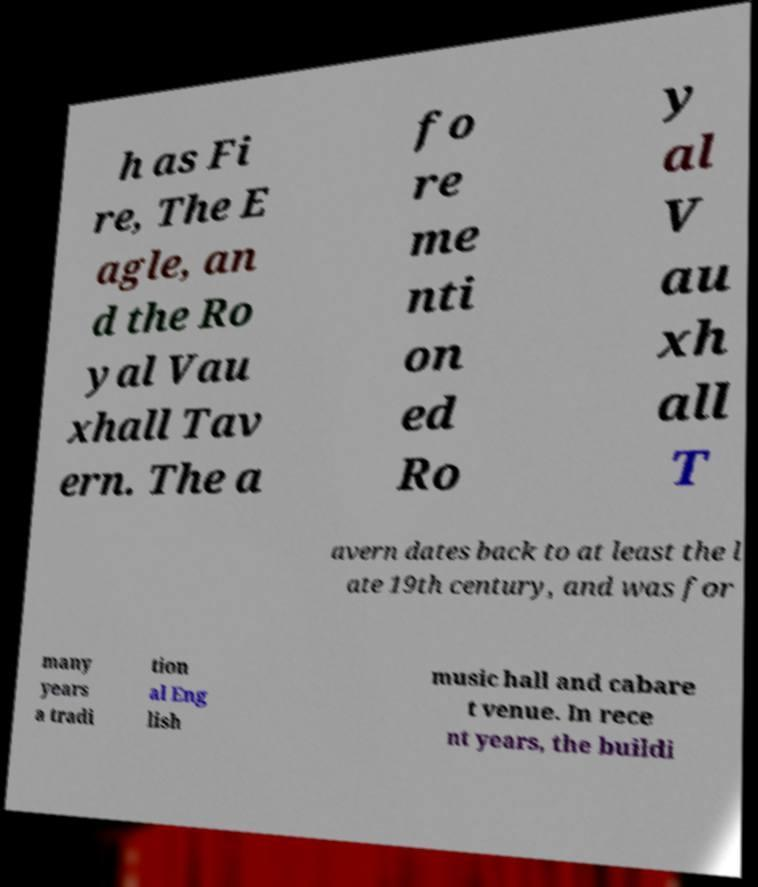Please identify and transcribe the text found in this image. h as Fi re, The E agle, an d the Ro yal Vau xhall Tav ern. The a fo re me nti on ed Ro y al V au xh all T avern dates back to at least the l ate 19th century, and was for many years a tradi tion al Eng lish music hall and cabare t venue. In rece nt years, the buildi 